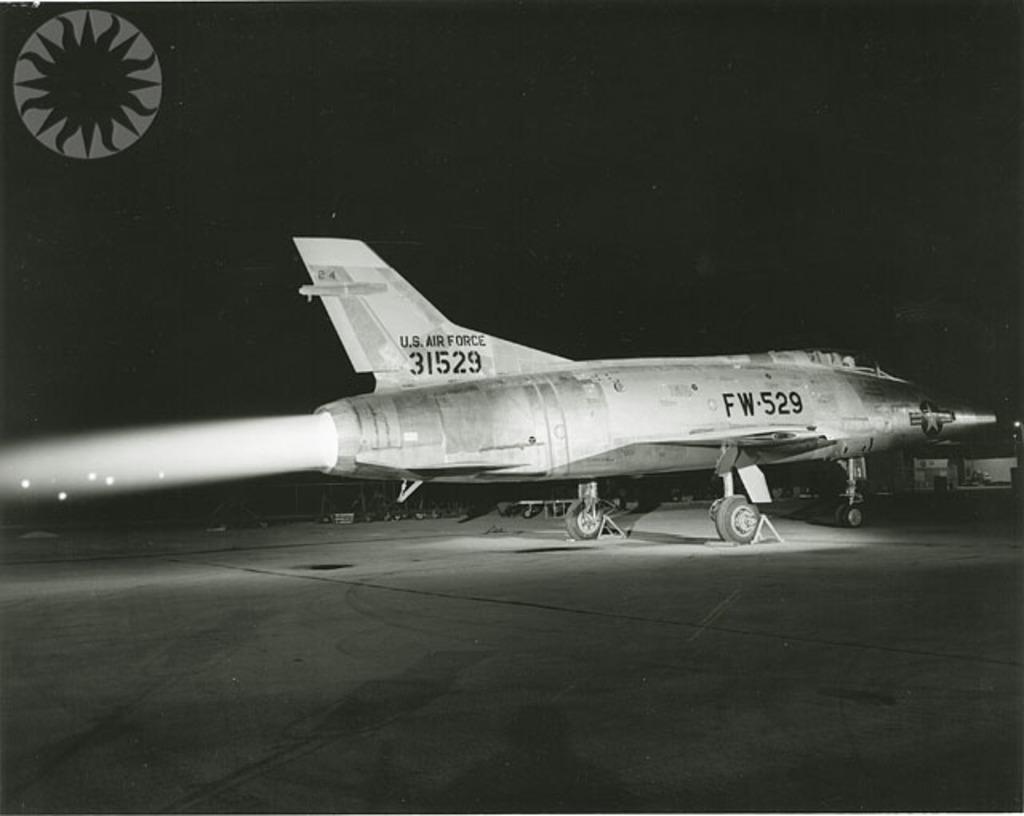Describe this image in one or two sentences. In this picture we can see an airplane on the ground, here we can see a logo, some objects and in the background we can see it is dark. 